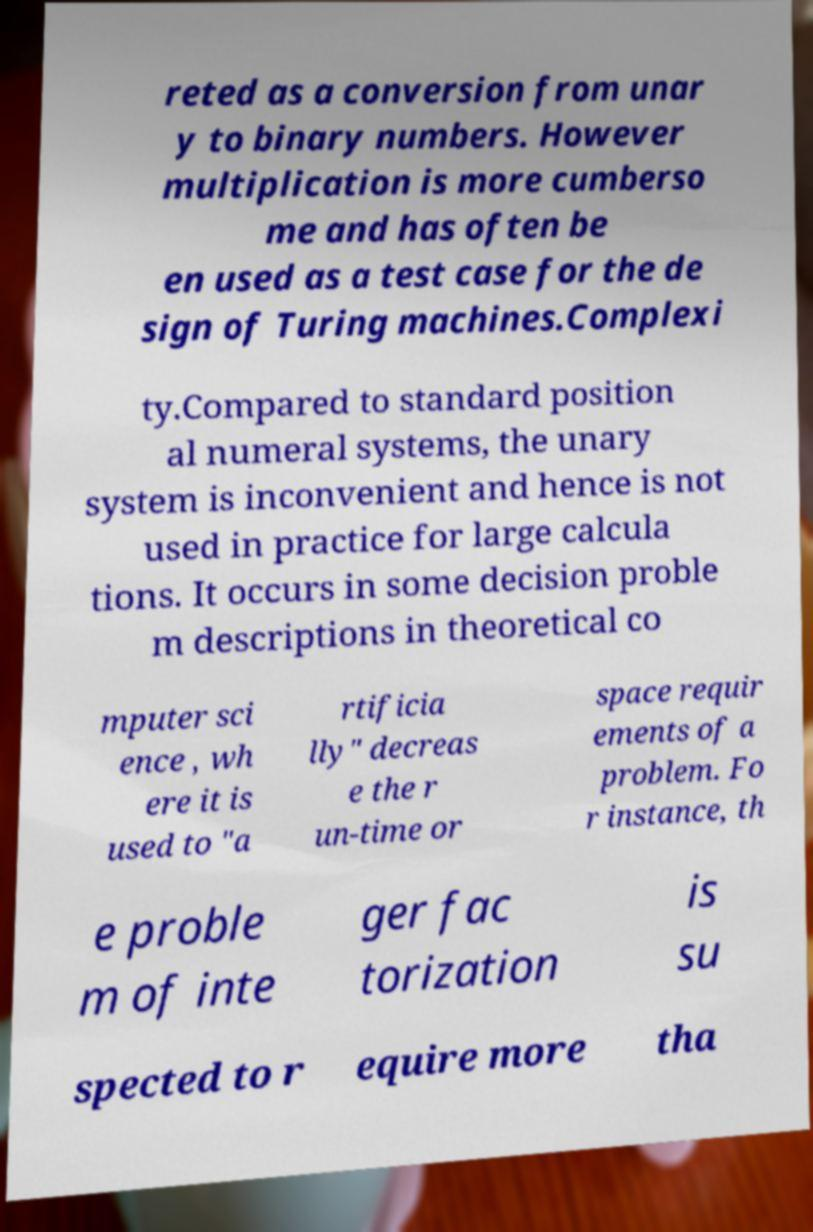There's text embedded in this image that I need extracted. Can you transcribe it verbatim? reted as a conversion from unar y to binary numbers. However multiplication is more cumberso me and has often be en used as a test case for the de sign of Turing machines.Complexi ty.Compared to standard position al numeral systems, the unary system is inconvenient and hence is not used in practice for large calcula tions. It occurs in some decision proble m descriptions in theoretical co mputer sci ence , wh ere it is used to "a rtificia lly" decreas e the r un-time or space requir ements of a problem. Fo r instance, th e proble m of inte ger fac torization is su spected to r equire more tha 